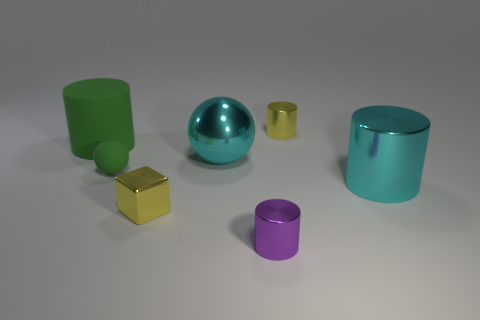There is a tiny object that is in front of the tiny metal cube; is there a tiny yellow metal cube that is on the right side of it?
Your answer should be very brief. No. There is a shiny thing that is left of the tiny purple cylinder and to the right of the small shiny cube; what size is it?
Keep it short and to the point. Large. What number of blue objects are either big shiny spheres or metallic cylinders?
Provide a short and direct response. 0. There is another rubber thing that is the same size as the purple object; what shape is it?
Offer a very short reply. Sphere. What size is the sphere in front of the cyan object that is left of the yellow metal cylinder?
Offer a terse response. Small. Is the material of the cylinder to the left of the purple cylinder the same as the small purple object?
Offer a terse response. No. There is a yellow object that is in front of the green matte sphere; what is its shape?
Give a very brief answer. Cube. How many purple shiny objects have the same size as the rubber cylinder?
Offer a terse response. 0. The cyan sphere is what size?
Make the answer very short. Large. There is a tiny green rubber object; how many matte balls are behind it?
Keep it short and to the point. 0. 